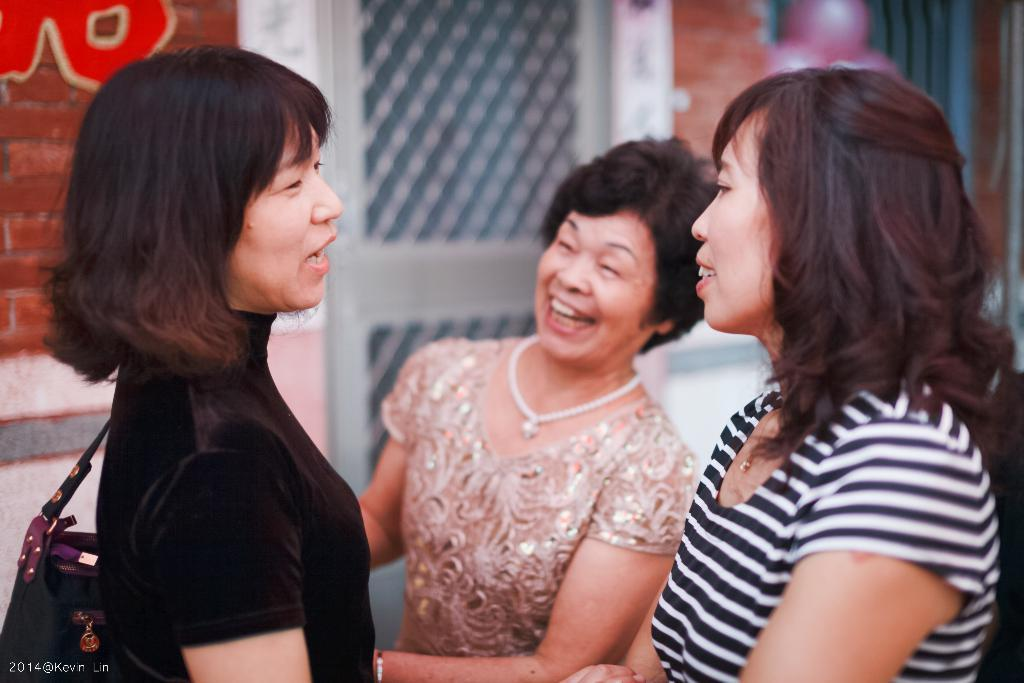How many women are present in the image? There are three women in the image. What is the facial expression of the women? The women are smiling. What can be seen in the background of the image? There is a building in the background of the image. What type of jewel can be seen on the ring worn by the woman on the left? There is no ring or jewel visible on any of the women in the image. 